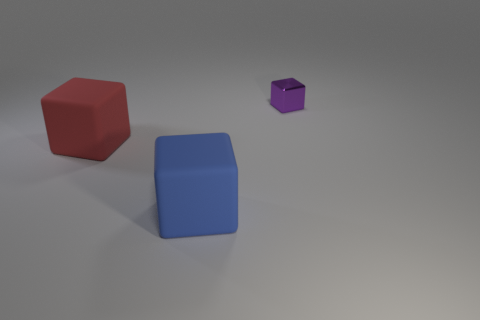Is there any other thing that is the same size as the purple metal cube?
Give a very brief answer. No. Is there any other thing that has the same material as the red object?
Your answer should be compact. Yes. Are there fewer shiny things right of the purple thing than blue rubber objects left of the blue rubber object?
Your answer should be compact. No. There is a red object; is its size the same as the thing behind the large red cube?
Provide a succinct answer. No. How many red rubber things have the same size as the purple metallic cube?
Offer a very short reply. 0. There is a large block that is made of the same material as the large red thing; what color is it?
Ensure brevity in your answer.  Blue. Are there more gray metallic objects than big red rubber blocks?
Offer a very short reply. No. Is the material of the big red cube the same as the blue cube?
Make the answer very short. Yes. There is another thing that is the same material as the large red thing; what shape is it?
Keep it short and to the point. Cube. Is the number of big objects less than the number of tiny objects?
Offer a terse response. No. 